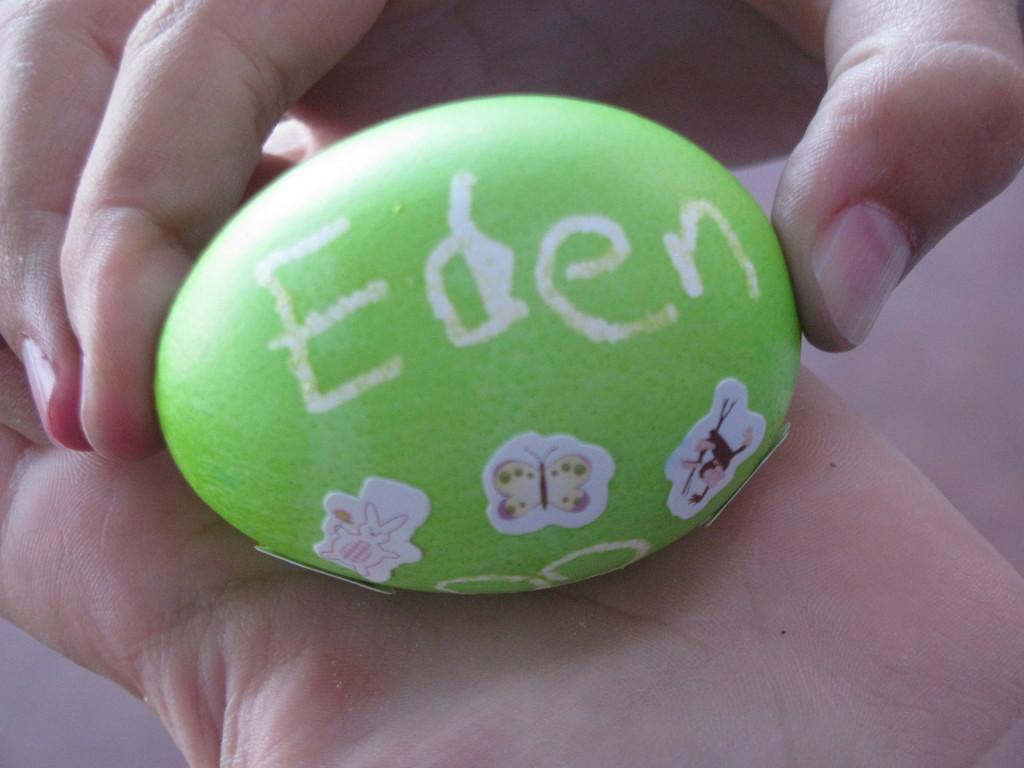What can be seen in the image? There is a person in the image. What is the person holding? The person is holding an object. Can you describe the object? The object is green in color, has an oval shape, and has tiny stickers on it. Is there any text on the object? Yes, there is writing on the object. What type of argument is the fireman having with the person in the image? There is no fireman or argument present in the image. How does the stomach of the person in the image look? The image does not show the person's stomach, so it cannot be described. 